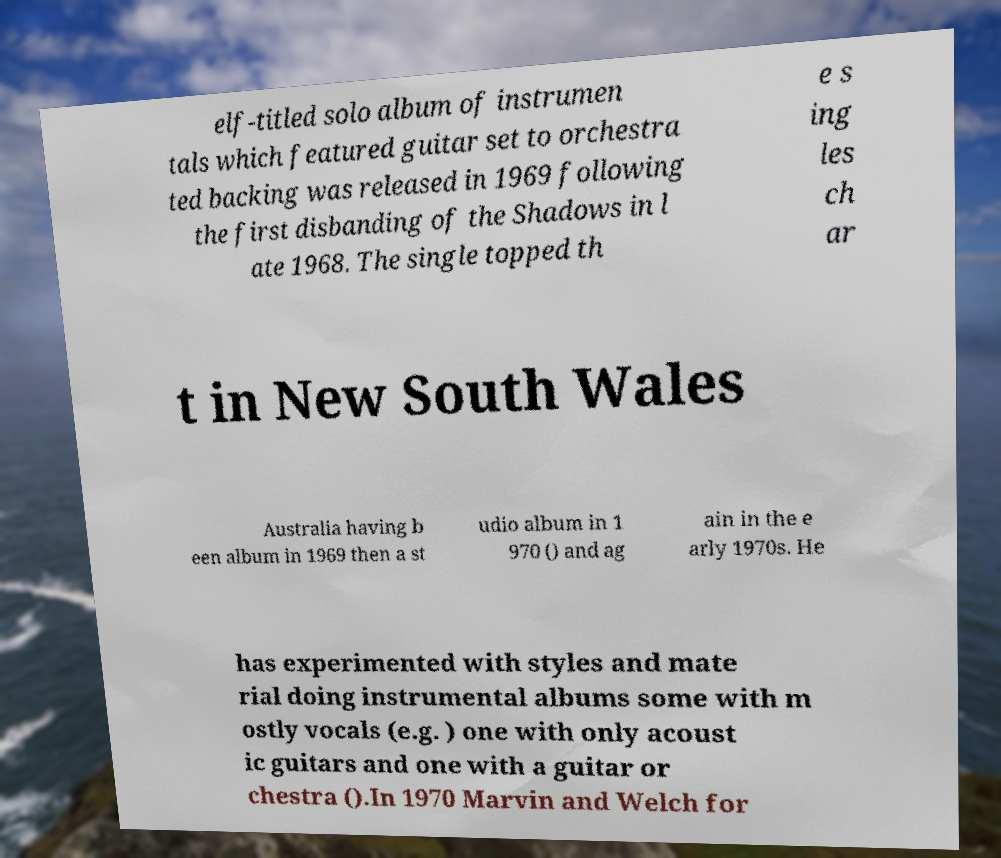Could you assist in decoding the text presented in this image and type it out clearly? elf-titled solo album of instrumen tals which featured guitar set to orchestra ted backing was released in 1969 following the first disbanding of the Shadows in l ate 1968. The single topped th e s ing les ch ar t in New South Wales Australia having b een album in 1969 then a st udio album in 1 970 () and ag ain in the e arly 1970s. He has experimented with styles and mate rial doing instrumental albums some with m ostly vocals (e.g. ) one with only acoust ic guitars and one with a guitar or chestra ().In 1970 Marvin and Welch for 